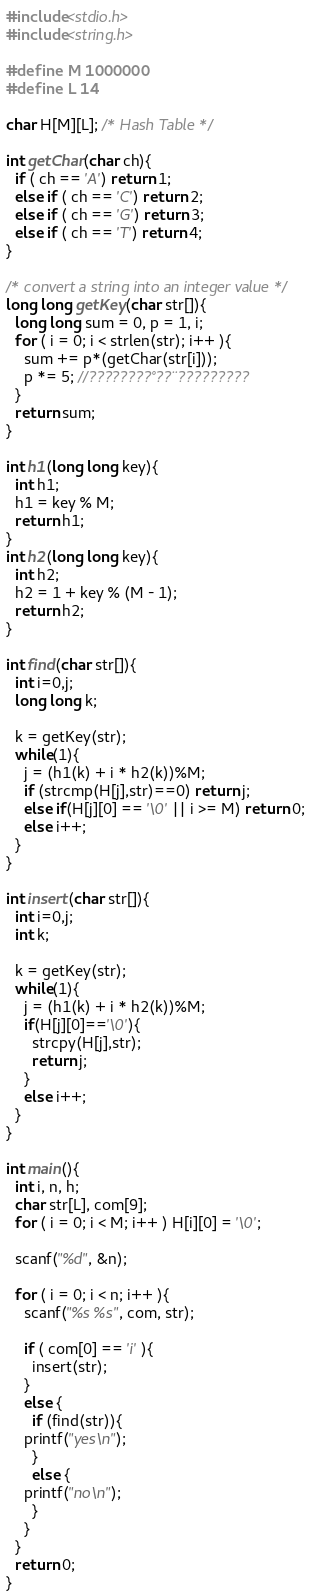Convert code to text. <code><loc_0><loc_0><loc_500><loc_500><_C_>#include<stdio.h>
#include<string.h>

#define M 1000000
#define L 14

char H[M][L]; /* Hash Table */

int getChar(char ch){
  if ( ch == 'A') return 1;
  else if ( ch == 'C') return 2;
  else if ( ch == 'G') return 3;
  else if ( ch == 'T') return 4;
}

/* convert a string into an integer value */
long long getKey(char str[]){
  long long sum = 0, p = 1, i;
  for ( i = 0; i < strlen(str); i++ ){
    sum += p*(getChar(str[i]));
    p *= 5; //????????°??¨?????????
  }
  return sum;
}

int h1(long long key){
  int h1;
  h1 = key % M;
  return h1;
}
int h2(long long key){
  int h2;
  h2 = 1 + key % (M - 1);
  return h2;
}

int find(char str[]){
  int i=0,j;
  long long k;
  
  k = getKey(str);
  while(1){
    j = (h1(k) + i * h2(k))%M;
    if (strcmp(H[j],str)==0) return j;
    else if(H[j][0] == '\0' || i >= M) return 0;
    else i++;
  }
}

int insert(char str[]){
  int i=0,j;
  int k;
  
  k = getKey(str);
  while(1){
    j = (h1(k) + i * h2(k))%M;
    if(H[j][0]=='\0'){
      strcpy(H[j],str);
      return j;
    }
    else i++;
  }
}

int main(){
  int i, n, h;
  char str[L], com[9];
  for ( i = 0; i < M; i++ ) H[i][0] = '\0';
    
  scanf("%d", &n);
    
  for ( i = 0; i < n; i++ ){
    scanf("%s %s", com, str);
	
    if ( com[0] == 'i' ){
      insert(str);
    }
    else {
      if (find(str)){
	printf("yes\n");
      }
      else {
	printf("no\n");
      }
    }
  }
  return 0;
}</code> 